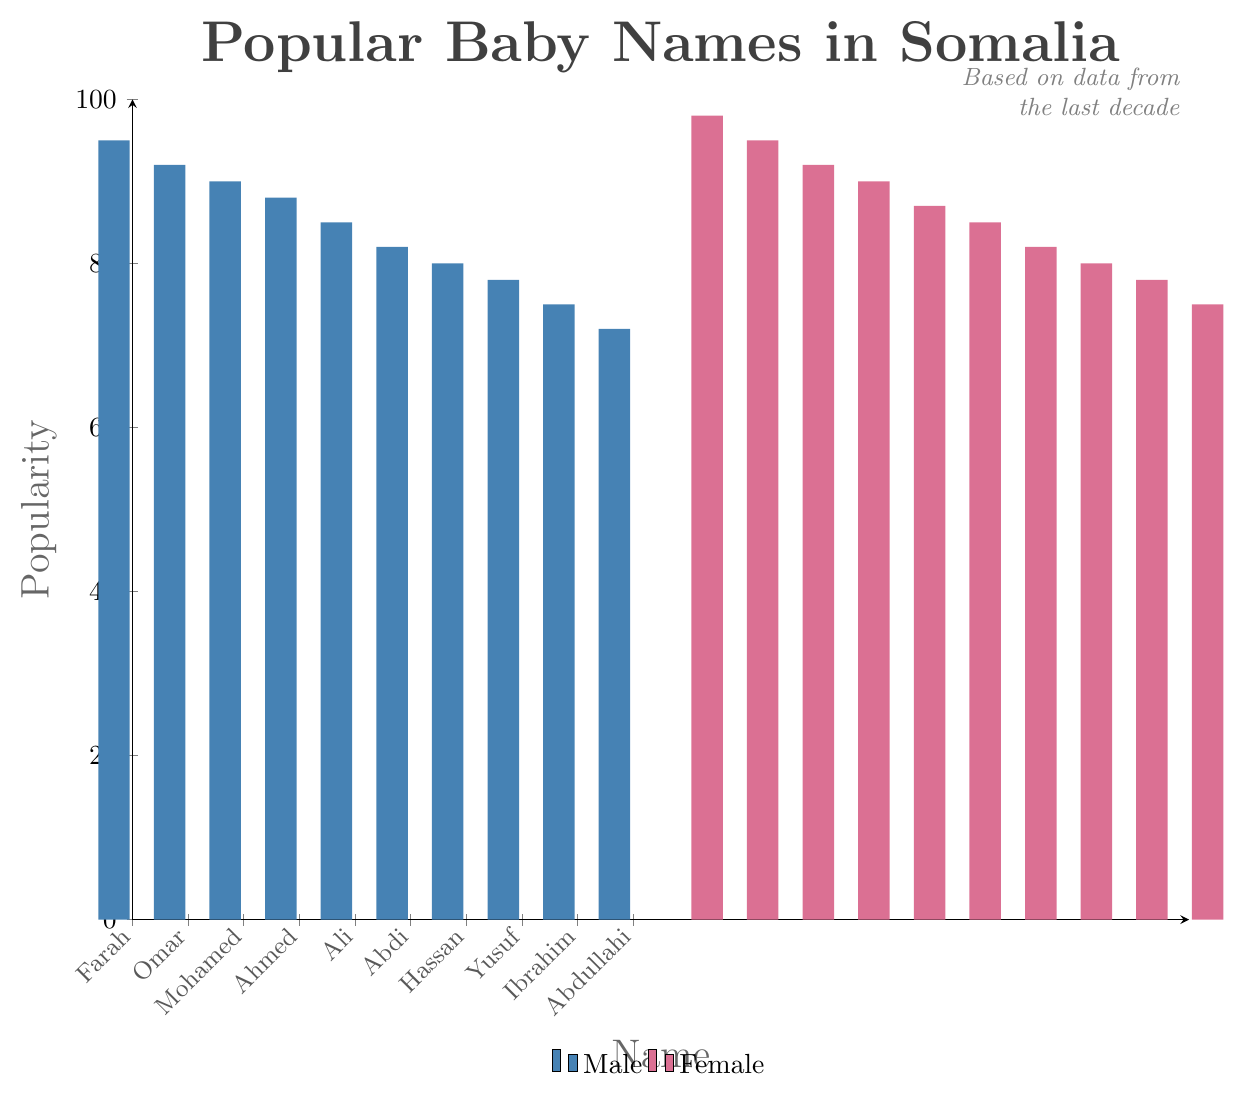Which baby name is the most popular among boys in Somalia over the last decade? The bar representing 'Farah' for males is the highest among male names.
Answer: Farah Which baby name is the most popular among girls in Somalia over the last decade? The bar representing 'Amina' for females is the highest among female names.
Answer: Amina How much more popular is the name 'Amina' compared to 'Fatima'? The popularity of 'Amina' is 98, and the popularity of 'Fatima' is 95. The difference is 98 - 95.
Answer: 3 Which has a higher popularity: 'Farah' or 'Omar'? The bar height for 'Farah' is 95, while the bar height for 'Omar' is 92. Therefore, 'Farah' is higher.
Answer: Farah Among female names, which name has the lowest popularity? The bar representing 'Khadija' for females is the lowest among the female names.
Answer: Khadija What is the average popularity of the top three male names? The top three male names are 'Farah' (95), 'Omar' (92), and 'Mohamed' (90). Calculate the average: (95 + 92 + 90) / 3.
Answer: 92.33 Compare the total popularity of 'Ali', 'Hodan', and 'Yusuf'. Which is the most popular? The popularity of 'Ali' is 85, 'Hodan' is 82, and 'Yusuf' is 78. 'Ali' has the highest individual popularity.
Answer: Ali How many points higher is the popularity of 'Fatima' than 'Ibrahim'? The popularity of 'Fatima' is 95, and the popularity of 'Ibrahim' is 75. The difference is 95 - 75.
Answer: 20 What is the median popularity value of the male names? List the popularity values of male names in order: 72, 75, 78, 80, 82, 85, 88, 90, 92, 95. The median value, being the middle value in this sorted list, is 85.
Answer: 85 Between 'Maryan' and 'Asha', which name has higher popularity and by how much? The popularity of 'Maryan' is 92 and for 'Asha' is 90. 'Maryan' is higher by 92 - 90.
Answer: Maryan, 2 